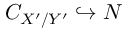Convert formula to latex. <formula><loc_0><loc_0><loc_500><loc_500>C _ { X ^ { \prime } / Y ^ { \prime } } \hookrightarrow N</formula> 